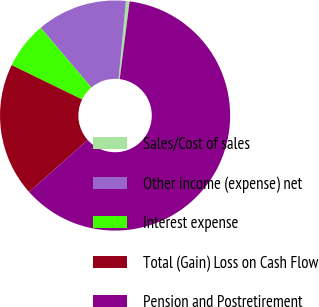Convert chart. <chart><loc_0><loc_0><loc_500><loc_500><pie_chart><fcel>Sales/Cost of sales<fcel>Other income (expense) net<fcel>Interest expense<fcel>Total (Gain) Loss on Cash Flow<fcel>Pension and Postretirement<nl><fcel>0.51%<fcel>12.69%<fcel>6.6%<fcel>18.78%<fcel>61.42%<nl></chart> 